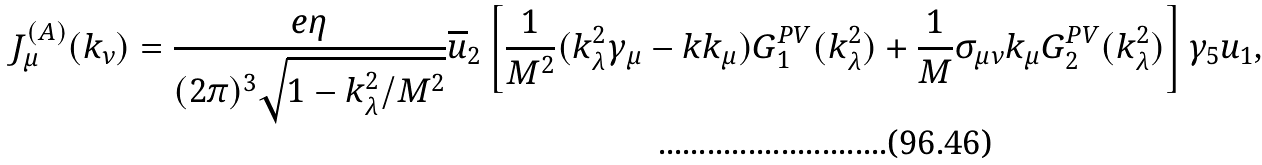Convert formula to latex. <formula><loc_0><loc_0><loc_500><loc_500>J ^ { ( A ) } _ { \mu } ( k _ { \nu } ) = \frac { e \eta } { ( 2 \pi ) ^ { 3 } \sqrt { 1 - k ^ { 2 } _ { \lambda } / M ^ { 2 } } } \overline { u } _ { 2 } \left [ \frac { 1 } { M ^ { 2 } } ( k ^ { 2 } _ { \lambda } \gamma _ { \mu } - k k _ { \mu } ) G ^ { P V } _ { 1 } ( k ^ { 2 } _ { \lambda } ) + \frac { 1 } { M } \sigma _ { \mu \nu } k _ { \mu } G ^ { P V } _ { 2 } ( k ^ { 2 } _ { \lambda } ) \right ] \gamma _ { 5 } u _ { 1 } ,</formula> 